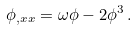Convert formula to latex. <formula><loc_0><loc_0><loc_500><loc_500>\phi _ { , x x } = \omega \phi - 2 \phi ^ { 3 } \, .</formula> 